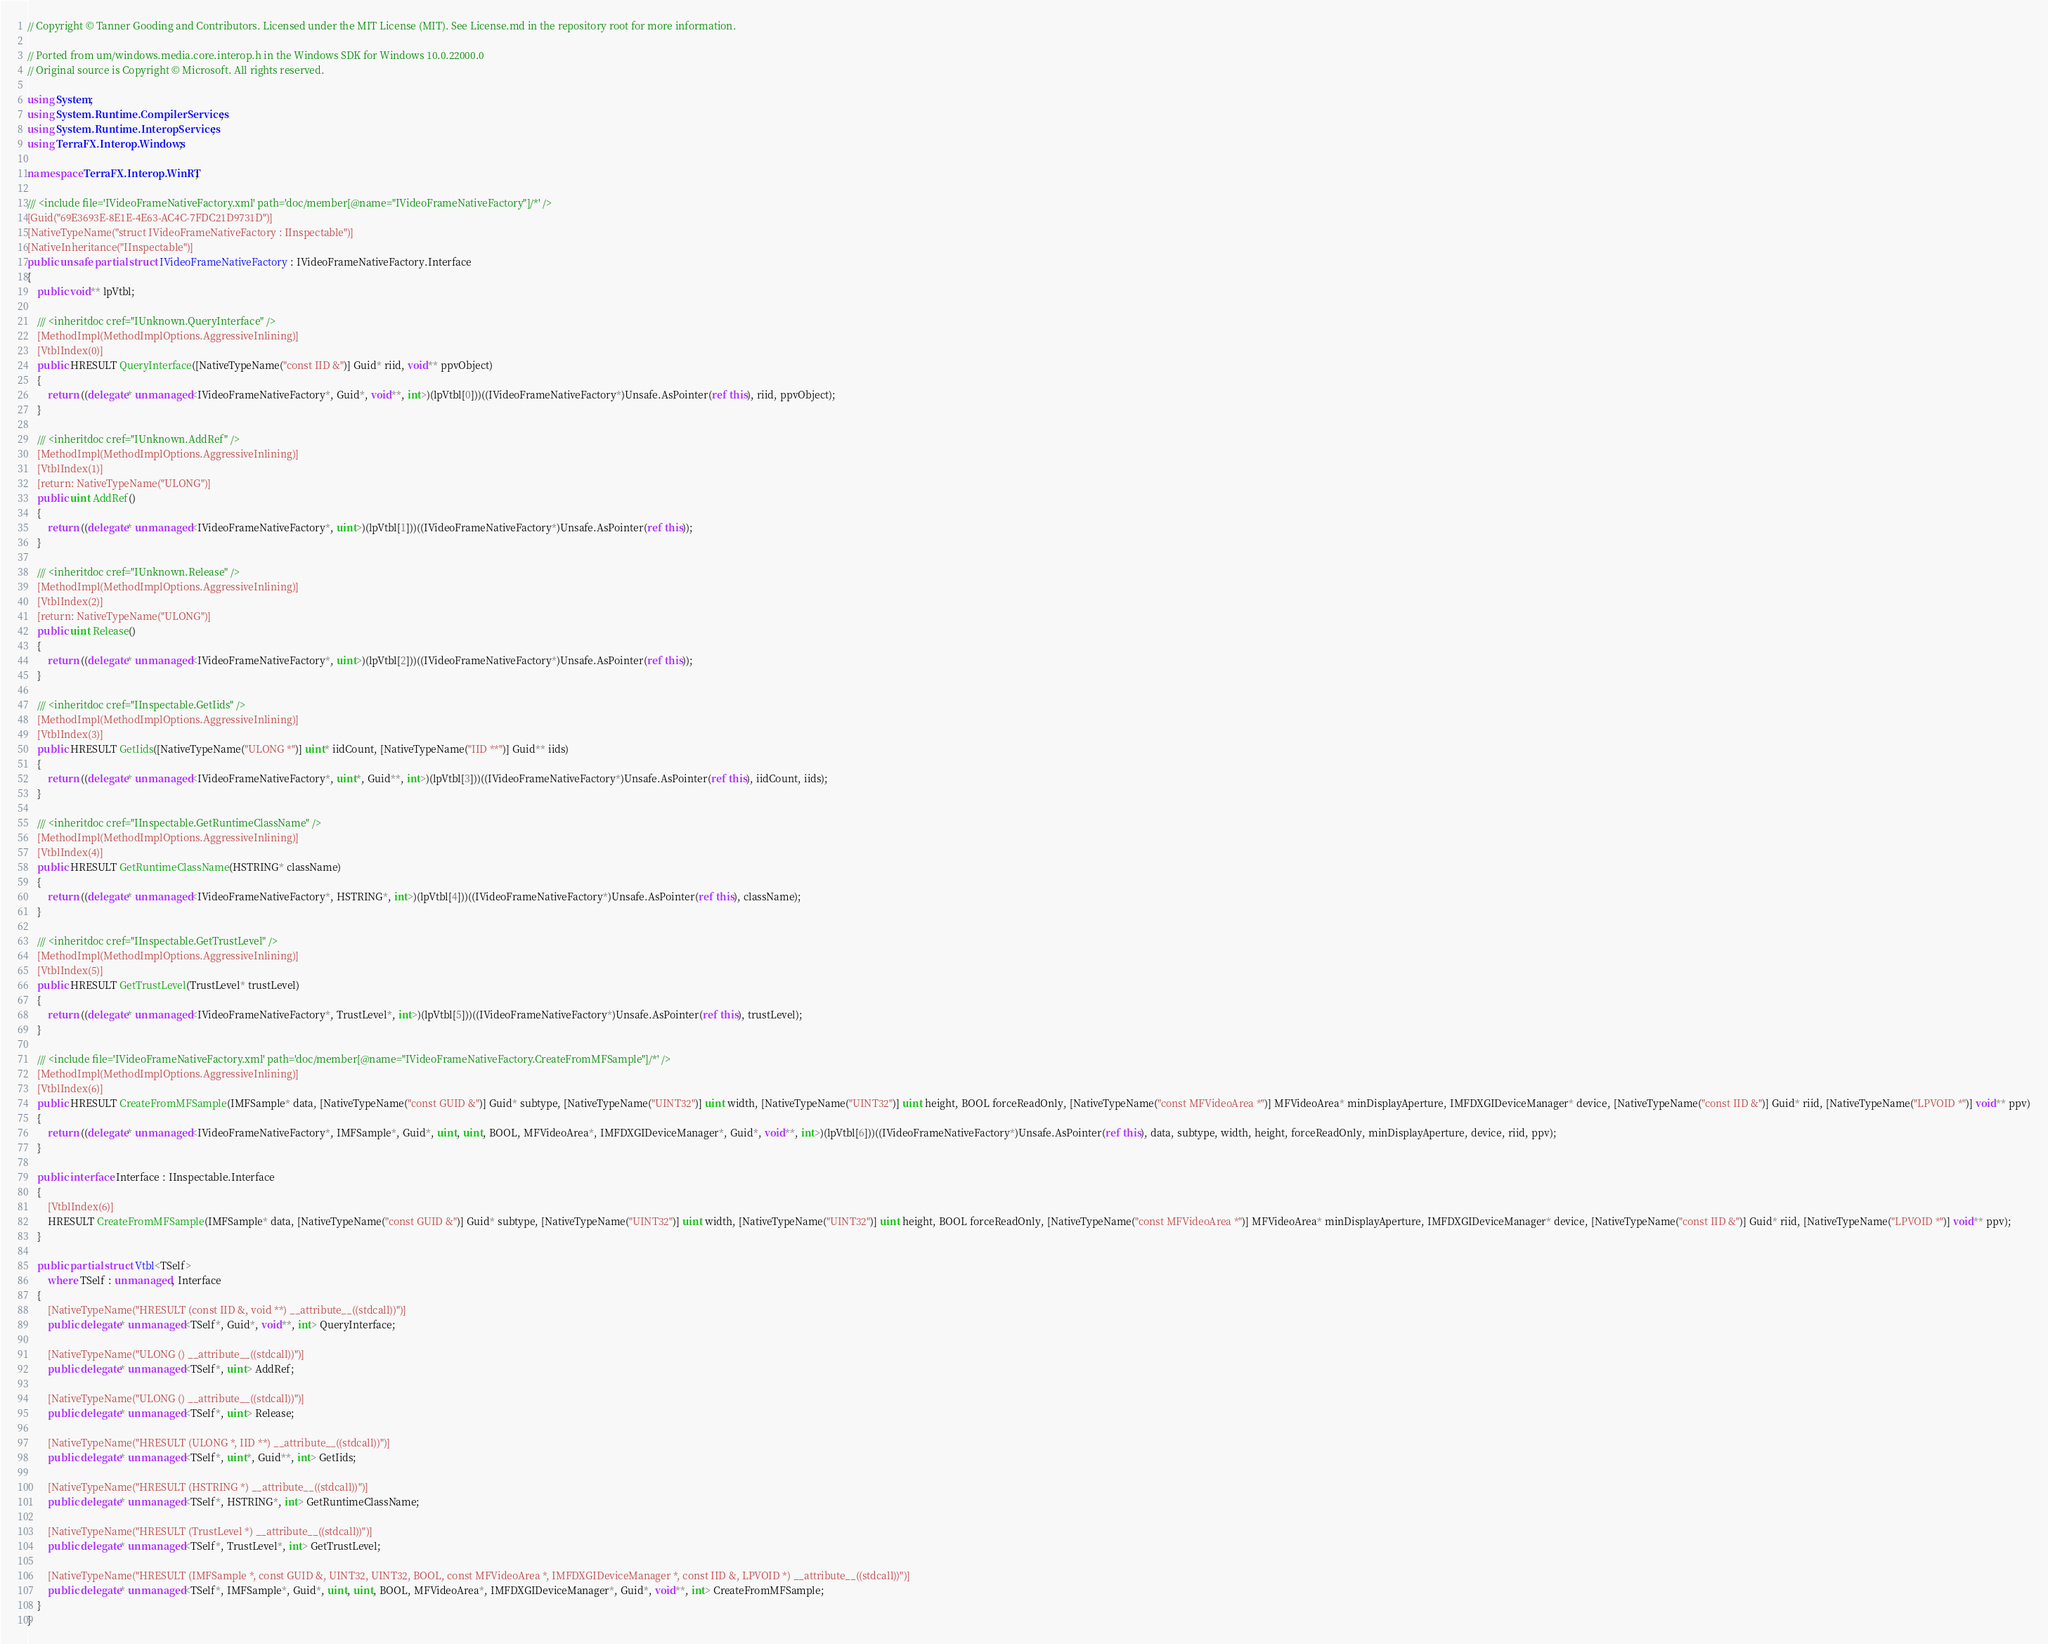<code> <loc_0><loc_0><loc_500><loc_500><_C#_>// Copyright © Tanner Gooding and Contributors. Licensed under the MIT License (MIT). See License.md in the repository root for more information.

// Ported from um/windows.media.core.interop.h in the Windows SDK for Windows 10.0.22000.0
// Original source is Copyright © Microsoft. All rights reserved.

using System;
using System.Runtime.CompilerServices;
using System.Runtime.InteropServices;
using TerraFX.Interop.Windows;

namespace TerraFX.Interop.WinRT;

/// <include file='IVideoFrameNativeFactory.xml' path='doc/member[@name="IVideoFrameNativeFactory"]/*' />
[Guid("69E3693E-8E1E-4E63-AC4C-7FDC21D9731D")]
[NativeTypeName("struct IVideoFrameNativeFactory : IInspectable")]
[NativeInheritance("IInspectable")]
public unsafe partial struct IVideoFrameNativeFactory : IVideoFrameNativeFactory.Interface
{
    public void** lpVtbl;

    /// <inheritdoc cref="IUnknown.QueryInterface" />
    [MethodImpl(MethodImplOptions.AggressiveInlining)]
    [VtblIndex(0)]
    public HRESULT QueryInterface([NativeTypeName("const IID &")] Guid* riid, void** ppvObject)
    {
        return ((delegate* unmanaged<IVideoFrameNativeFactory*, Guid*, void**, int>)(lpVtbl[0]))((IVideoFrameNativeFactory*)Unsafe.AsPointer(ref this), riid, ppvObject);
    }

    /// <inheritdoc cref="IUnknown.AddRef" />
    [MethodImpl(MethodImplOptions.AggressiveInlining)]
    [VtblIndex(1)]
    [return: NativeTypeName("ULONG")]
    public uint AddRef()
    {
        return ((delegate* unmanaged<IVideoFrameNativeFactory*, uint>)(lpVtbl[1]))((IVideoFrameNativeFactory*)Unsafe.AsPointer(ref this));
    }

    /// <inheritdoc cref="IUnknown.Release" />
    [MethodImpl(MethodImplOptions.AggressiveInlining)]
    [VtblIndex(2)]
    [return: NativeTypeName("ULONG")]
    public uint Release()
    {
        return ((delegate* unmanaged<IVideoFrameNativeFactory*, uint>)(lpVtbl[2]))((IVideoFrameNativeFactory*)Unsafe.AsPointer(ref this));
    }

    /// <inheritdoc cref="IInspectable.GetIids" />
    [MethodImpl(MethodImplOptions.AggressiveInlining)]
    [VtblIndex(3)]
    public HRESULT GetIids([NativeTypeName("ULONG *")] uint* iidCount, [NativeTypeName("IID **")] Guid** iids)
    {
        return ((delegate* unmanaged<IVideoFrameNativeFactory*, uint*, Guid**, int>)(lpVtbl[3]))((IVideoFrameNativeFactory*)Unsafe.AsPointer(ref this), iidCount, iids);
    }

    /// <inheritdoc cref="IInspectable.GetRuntimeClassName" />
    [MethodImpl(MethodImplOptions.AggressiveInlining)]
    [VtblIndex(4)]
    public HRESULT GetRuntimeClassName(HSTRING* className)
    {
        return ((delegate* unmanaged<IVideoFrameNativeFactory*, HSTRING*, int>)(lpVtbl[4]))((IVideoFrameNativeFactory*)Unsafe.AsPointer(ref this), className);
    }

    /// <inheritdoc cref="IInspectable.GetTrustLevel" />
    [MethodImpl(MethodImplOptions.AggressiveInlining)]
    [VtblIndex(5)]
    public HRESULT GetTrustLevel(TrustLevel* trustLevel)
    {
        return ((delegate* unmanaged<IVideoFrameNativeFactory*, TrustLevel*, int>)(lpVtbl[5]))((IVideoFrameNativeFactory*)Unsafe.AsPointer(ref this), trustLevel);
    }

    /// <include file='IVideoFrameNativeFactory.xml' path='doc/member[@name="IVideoFrameNativeFactory.CreateFromMFSample"]/*' />
    [MethodImpl(MethodImplOptions.AggressiveInlining)]
    [VtblIndex(6)]
    public HRESULT CreateFromMFSample(IMFSample* data, [NativeTypeName("const GUID &")] Guid* subtype, [NativeTypeName("UINT32")] uint width, [NativeTypeName("UINT32")] uint height, BOOL forceReadOnly, [NativeTypeName("const MFVideoArea *")] MFVideoArea* minDisplayAperture, IMFDXGIDeviceManager* device, [NativeTypeName("const IID &")] Guid* riid, [NativeTypeName("LPVOID *")] void** ppv)
    {
        return ((delegate* unmanaged<IVideoFrameNativeFactory*, IMFSample*, Guid*, uint, uint, BOOL, MFVideoArea*, IMFDXGIDeviceManager*, Guid*, void**, int>)(lpVtbl[6]))((IVideoFrameNativeFactory*)Unsafe.AsPointer(ref this), data, subtype, width, height, forceReadOnly, minDisplayAperture, device, riid, ppv);
    }

    public interface Interface : IInspectable.Interface
    {
        [VtblIndex(6)]
        HRESULT CreateFromMFSample(IMFSample* data, [NativeTypeName("const GUID &")] Guid* subtype, [NativeTypeName("UINT32")] uint width, [NativeTypeName("UINT32")] uint height, BOOL forceReadOnly, [NativeTypeName("const MFVideoArea *")] MFVideoArea* minDisplayAperture, IMFDXGIDeviceManager* device, [NativeTypeName("const IID &")] Guid* riid, [NativeTypeName("LPVOID *")] void** ppv);
    }

    public partial struct Vtbl<TSelf>
        where TSelf : unmanaged, Interface
    {
        [NativeTypeName("HRESULT (const IID &, void **) __attribute__((stdcall))")]
        public delegate* unmanaged<TSelf*, Guid*, void**, int> QueryInterface;

        [NativeTypeName("ULONG () __attribute__((stdcall))")]
        public delegate* unmanaged<TSelf*, uint> AddRef;

        [NativeTypeName("ULONG () __attribute__((stdcall))")]
        public delegate* unmanaged<TSelf*, uint> Release;

        [NativeTypeName("HRESULT (ULONG *, IID **) __attribute__((stdcall))")]
        public delegate* unmanaged<TSelf*, uint*, Guid**, int> GetIids;

        [NativeTypeName("HRESULT (HSTRING *) __attribute__((stdcall))")]
        public delegate* unmanaged<TSelf*, HSTRING*, int> GetRuntimeClassName;

        [NativeTypeName("HRESULT (TrustLevel *) __attribute__((stdcall))")]
        public delegate* unmanaged<TSelf*, TrustLevel*, int> GetTrustLevel;

        [NativeTypeName("HRESULT (IMFSample *, const GUID &, UINT32, UINT32, BOOL, const MFVideoArea *, IMFDXGIDeviceManager *, const IID &, LPVOID *) __attribute__((stdcall))")]
        public delegate* unmanaged<TSelf*, IMFSample*, Guid*, uint, uint, BOOL, MFVideoArea*, IMFDXGIDeviceManager*, Guid*, void**, int> CreateFromMFSample;
    }
}
</code> 